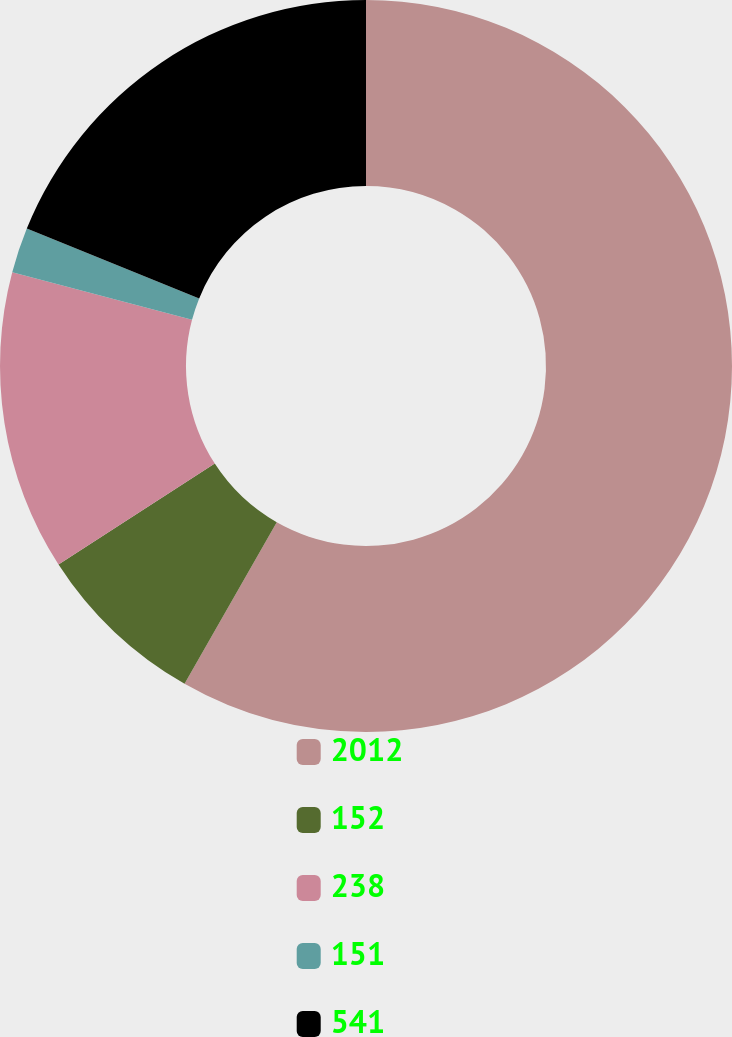<chart> <loc_0><loc_0><loc_500><loc_500><pie_chart><fcel>2012<fcel>152<fcel>238<fcel>151<fcel>541<nl><fcel>58.25%<fcel>7.62%<fcel>13.25%<fcel>2.0%<fcel>18.87%<nl></chart> 